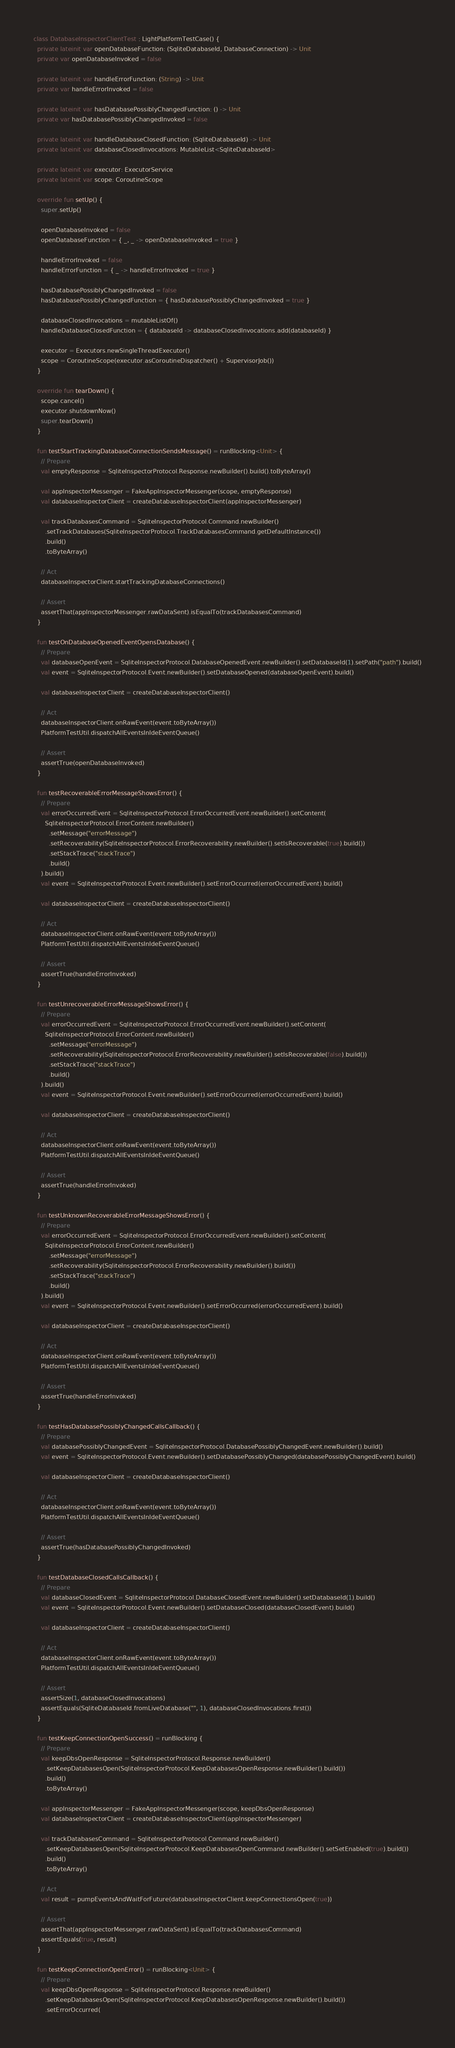Convert code to text. <code><loc_0><loc_0><loc_500><loc_500><_Kotlin_>class DatabaseInspectorClientTest : LightPlatformTestCase() {
  private lateinit var openDatabaseFunction: (SqliteDatabaseId, DatabaseConnection) -> Unit
  private var openDatabaseInvoked = false

  private lateinit var handleErrorFunction: (String) -> Unit
  private var handleErrorInvoked = false

  private lateinit var hasDatabasePossiblyChangedFunction: () -> Unit
  private var hasDatabasePossiblyChangedInvoked = false

  private lateinit var handleDatabaseClosedFunction: (SqliteDatabaseId) -> Unit
  private lateinit var databaseClosedInvocations: MutableList<SqliteDatabaseId>

  private lateinit var executor: ExecutorService
  private lateinit var scope: CoroutineScope

  override fun setUp() {
    super.setUp()

    openDatabaseInvoked = false
    openDatabaseFunction = { _, _ -> openDatabaseInvoked = true }

    handleErrorInvoked = false
    handleErrorFunction = { _ -> handleErrorInvoked = true }

    hasDatabasePossiblyChangedInvoked = false
    hasDatabasePossiblyChangedFunction = { hasDatabasePossiblyChangedInvoked = true }

    databaseClosedInvocations = mutableListOf()
    handleDatabaseClosedFunction = { databaseId -> databaseClosedInvocations.add(databaseId) }

    executor = Executors.newSingleThreadExecutor()
    scope = CoroutineScope(executor.asCoroutineDispatcher() + SupervisorJob())
  }

  override fun tearDown() {
    scope.cancel()
    executor.shutdownNow()
    super.tearDown()
  }

  fun testStartTrackingDatabaseConnectionSendsMessage() = runBlocking<Unit> {
    // Prepare
    val emptyResponse = SqliteInspectorProtocol.Response.newBuilder().build().toByteArray()

    val appInspectorMessenger = FakeAppInspectorMessenger(scope, emptyResponse)
    val databaseInspectorClient = createDatabaseInspectorClient(appInspectorMessenger)

    val trackDatabasesCommand = SqliteInspectorProtocol.Command.newBuilder()
      .setTrackDatabases(SqliteInspectorProtocol.TrackDatabasesCommand.getDefaultInstance())
      .build()
      .toByteArray()

    // Act
    databaseInspectorClient.startTrackingDatabaseConnections()

    // Assert
    assertThat(appInspectorMessenger.rawDataSent).isEqualTo(trackDatabasesCommand)
  }

  fun testOnDatabaseOpenedEventOpensDatabase() {
    // Prepare
    val databaseOpenEvent = SqliteInspectorProtocol.DatabaseOpenedEvent.newBuilder().setDatabaseId(1).setPath("path").build()
    val event = SqliteInspectorProtocol.Event.newBuilder().setDatabaseOpened(databaseOpenEvent).build()

    val databaseInspectorClient = createDatabaseInspectorClient()

    // Act
    databaseInspectorClient.onRawEvent(event.toByteArray())
    PlatformTestUtil.dispatchAllEventsInIdeEventQueue()

    // Assert
    assertTrue(openDatabaseInvoked)
  }

  fun testRecoverableErrorMessageShowsError() {
    // Prepare
    val errorOccurredEvent = SqliteInspectorProtocol.ErrorOccurredEvent.newBuilder().setContent(
      SqliteInspectorProtocol.ErrorContent.newBuilder()
        .setMessage("errorMessage")
        .setRecoverability(SqliteInspectorProtocol.ErrorRecoverability.newBuilder().setIsRecoverable(true).build())
        .setStackTrace("stackTrace")
        .build()
    ).build()
    val event = SqliteInspectorProtocol.Event.newBuilder().setErrorOccurred(errorOccurredEvent).build()

    val databaseInspectorClient = createDatabaseInspectorClient()

    // Act
    databaseInspectorClient.onRawEvent(event.toByteArray())
    PlatformTestUtil.dispatchAllEventsInIdeEventQueue()

    // Assert
    assertTrue(handleErrorInvoked)
  }

  fun testUnrecoverableErrorMessageShowsError() {
    // Prepare
    val errorOccurredEvent = SqliteInspectorProtocol.ErrorOccurredEvent.newBuilder().setContent(
      SqliteInspectorProtocol.ErrorContent.newBuilder()
        .setMessage("errorMessage")
        .setRecoverability(SqliteInspectorProtocol.ErrorRecoverability.newBuilder().setIsRecoverable(false).build())
        .setStackTrace("stackTrace")
        .build()
    ).build()
    val event = SqliteInspectorProtocol.Event.newBuilder().setErrorOccurred(errorOccurredEvent).build()

    val databaseInspectorClient = createDatabaseInspectorClient()

    // Act
    databaseInspectorClient.onRawEvent(event.toByteArray())
    PlatformTestUtil.dispatchAllEventsInIdeEventQueue()

    // Assert
    assertTrue(handleErrorInvoked)
  }

  fun testUnknownRecoverableErrorMessageShowsError() {
    // Prepare
    val errorOccurredEvent = SqliteInspectorProtocol.ErrorOccurredEvent.newBuilder().setContent(
      SqliteInspectorProtocol.ErrorContent.newBuilder()
        .setMessage("errorMessage")
        .setRecoverability(SqliteInspectorProtocol.ErrorRecoverability.newBuilder().build())
        .setStackTrace("stackTrace")
        .build()
    ).build()
    val event = SqliteInspectorProtocol.Event.newBuilder().setErrorOccurred(errorOccurredEvent).build()

    val databaseInspectorClient = createDatabaseInspectorClient()

    // Act
    databaseInspectorClient.onRawEvent(event.toByteArray())
    PlatformTestUtil.dispatchAllEventsInIdeEventQueue()

    // Assert
    assertTrue(handleErrorInvoked)
  }

  fun testHasDatabasePossiblyChangedCallsCallback() {
    // Prepare
    val databasePossiblyChangedEvent = SqliteInspectorProtocol.DatabasePossiblyChangedEvent.newBuilder().build()
    val event = SqliteInspectorProtocol.Event.newBuilder().setDatabasePossiblyChanged(databasePossiblyChangedEvent).build()

    val databaseInspectorClient = createDatabaseInspectorClient()

    // Act
    databaseInspectorClient.onRawEvent(event.toByteArray())
    PlatformTestUtil.dispatchAllEventsInIdeEventQueue()

    // Assert
    assertTrue(hasDatabasePossiblyChangedInvoked)
  }

  fun testDatabaseClosedCallsCallback() {
    // Prepare
    val databaseClosedEvent = SqliteInspectorProtocol.DatabaseClosedEvent.newBuilder().setDatabaseId(1).build()
    val event = SqliteInspectorProtocol.Event.newBuilder().setDatabaseClosed(databaseClosedEvent).build()

    val databaseInspectorClient = createDatabaseInspectorClient()

    // Act
    databaseInspectorClient.onRawEvent(event.toByteArray())
    PlatformTestUtil.dispatchAllEventsInIdeEventQueue()

    // Assert
    assertSize(1, databaseClosedInvocations)
    assertEquals(SqliteDatabaseId.fromLiveDatabase("", 1), databaseClosedInvocations.first())
  }

  fun testKeepConnectionOpenSuccess() = runBlocking {
    // Prepare
    val keepDbsOpenResponse = SqliteInspectorProtocol.Response.newBuilder()
      .setKeepDatabasesOpen(SqliteInspectorProtocol.KeepDatabasesOpenResponse.newBuilder().build())
      .build()
      .toByteArray()

    val appInspectorMessenger = FakeAppInspectorMessenger(scope, keepDbsOpenResponse)
    val databaseInspectorClient = createDatabaseInspectorClient(appInspectorMessenger)

    val trackDatabasesCommand = SqliteInspectorProtocol.Command.newBuilder()
      .setKeepDatabasesOpen(SqliteInspectorProtocol.KeepDatabasesOpenCommand.newBuilder().setSetEnabled(true).build())
      .build()
      .toByteArray()

    // Act
    val result = pumpEventsAndWaitForFuture(databaseInspectorClient.keepConnectionsOpen(true))

    // Assert
    assertThat(appInspectorMessenger.rawDataSent).isEqualTo(trackDatabasesCommand)
    assertEquals(true, result)
  }

  fun testKeepConnectionOpenError() = runBlocking<Unit> {
    // Prepare
    val keepDbsOpenResponse = SqliteInspectorProtocol.Response.newBuilder()
      .setKeepDatabasesOpen(SqliteInspectorProtocol.KeepDatabasesOpenResponse.newBuilder().build())
      .setErrorOccurred(</code> 